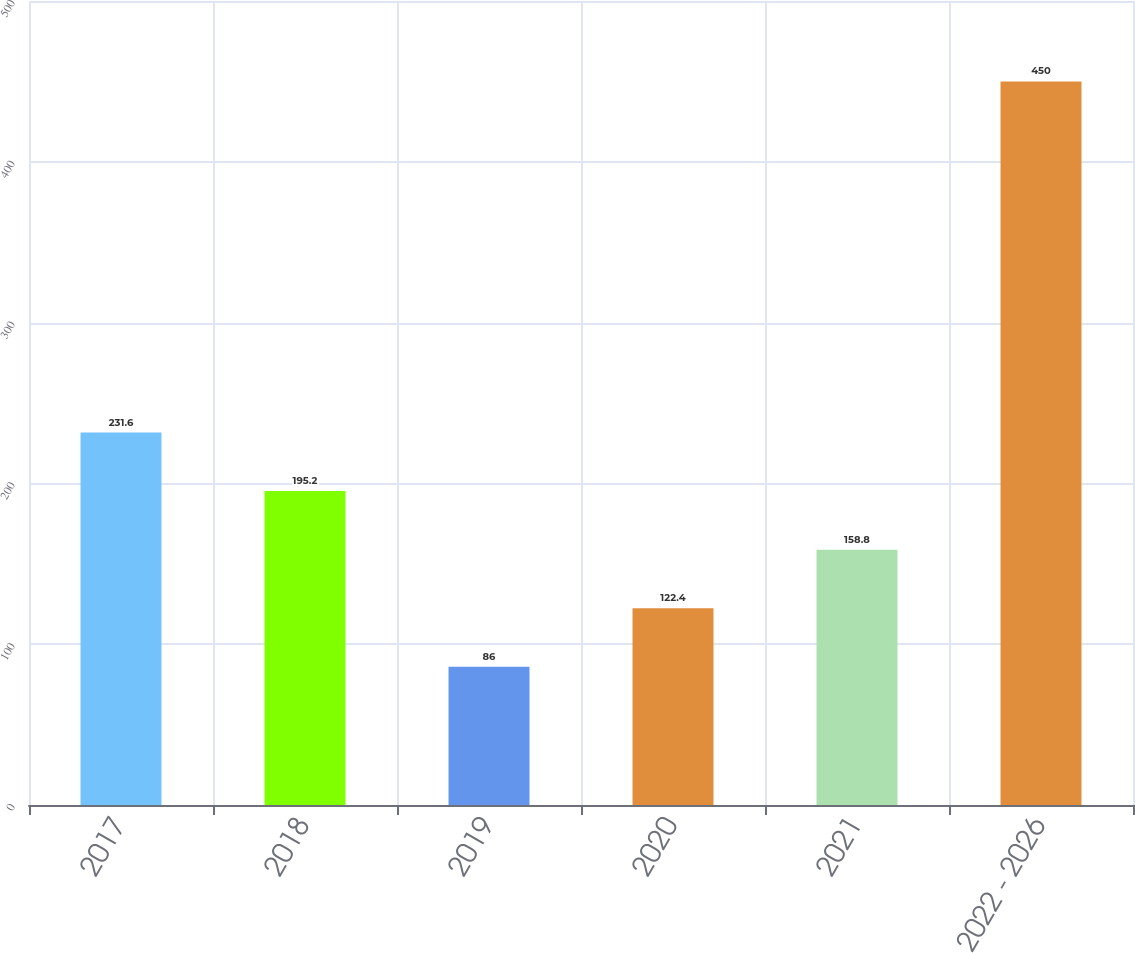Convert chart. <chart><loc_0><loc_0><loc_500><loc_500><bar_chart><fcel>2017<fcel>2018<fcel>2019<fcel>2020<fcel>2021<fcel>2022 - 2026<nl><fcel>231.6<fcel>195.2<fcel>86<fcel>122.4<fcel>158.8<fcel>450<nl></chart> 